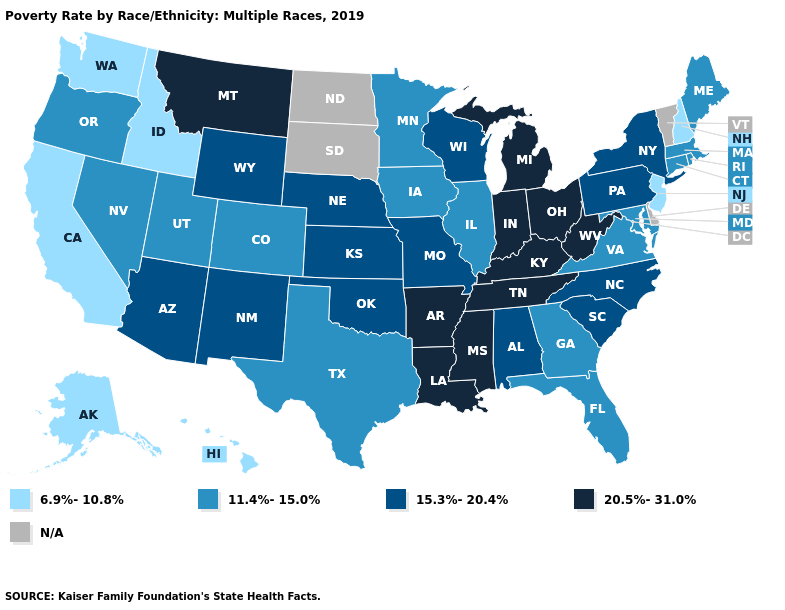What is the highest value in states that border Wyoming?
Be succinct. 20.5%-31.0%. Which states have the highest value in the USA?
Quick response, please. Arkansas, Indiana, Kentucky, Louisiana, Michigan, Mississippi, Montana, Ohio, Tennessee, West Virginia. How many symbols are there in the legend?
Write a very short answer. 5. What is the value of Louisiana?
Short answer required. 20.5%-31.0%. Name the states that have a value in the range 11.4%-15.0%?
Be succinct. Colorado, Connecticut, Florida, Georgia, Illinois, Iowa, Maine, Maryland, Massachusetts, Minnesota, Nevada, Oregon, Rhode Island, Texas, Utah, Virginia. What is the value of Wisconsin?
Give a very brief answer. 15.3%-20.4%. What is the highest value in states that border Idaho?
Write a very short answer. 20.5%-31.0%. What is the highest value in the West ?
Write a very short answer. 20.5%-31.0%. Name the states that have a value in the range 15.3%-20.4%?
Keep it brief. Alabama, Arizona, Kansas, Missouri, Nebraska, New Mexico, New York, North Carolina, Oklahoma, Pennsylvania, South Carolina, Wisconsin, Wyoming. Name the states that have a value in the range N/A?
Concise answer only. Delaware, North Dakota, South Dakota, Vermont. Which states have the lowest value in the USA?
Give a very brief answer. Alaska, California, Hawaii, Idaho, New Hampshire, New Jersey, Washington. How many symbols are there in the legend?
Write a very short answer. 5. What is the value of New Jersey?
Answer briefly. 6.9%-10.8%. What is the value of Missouri?
Answer briefly. 15.3%-20.4%. 